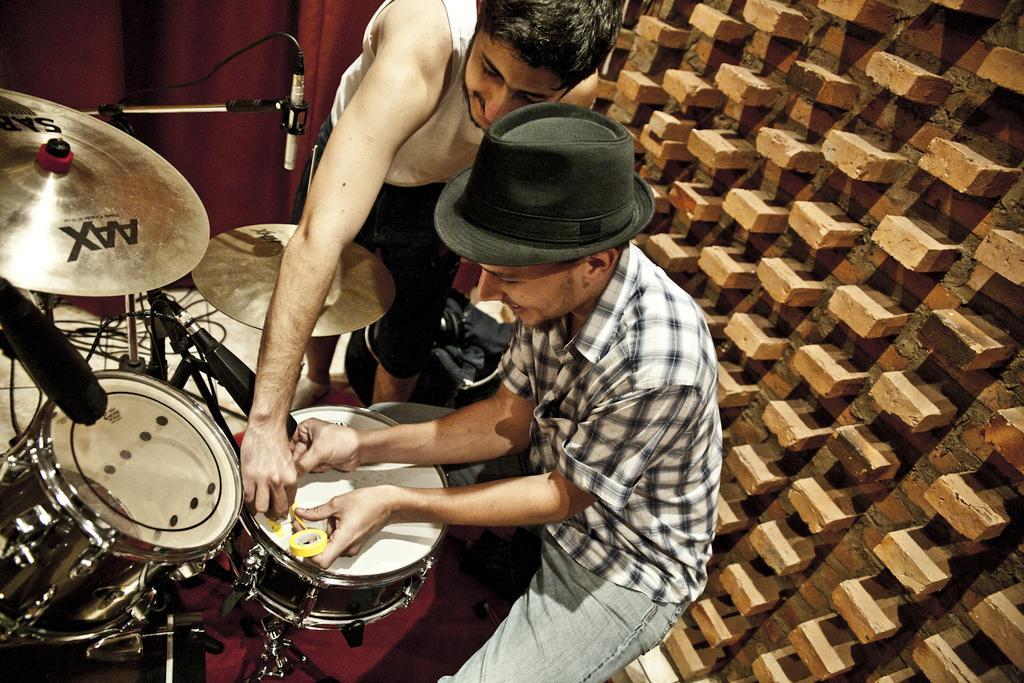How would you summarize this image in a sentence or two? This picture is clicked inside. On the left we can see some musical instruments. On the right there is a man wearing shirt and sitting and we can see another man holding some object and standing on the ground. In the background we can see the curtains and a brick wall. 